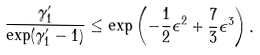Convert formula to latex. <formula><loc_0><loc_0><loc_500><loc_500>\frac { \gamma ^ { \prime } _ { 1 } } { \exp ( \gamma ^ { \prime } _ { 1 } - 1 ) } & \leq \exp \left ( - \frac { 1 } { 2 } \epsilon ^ { 2 } + \frac { 7 } { 3 } \epsilon ^ { 3 } \right ) .</formula> 